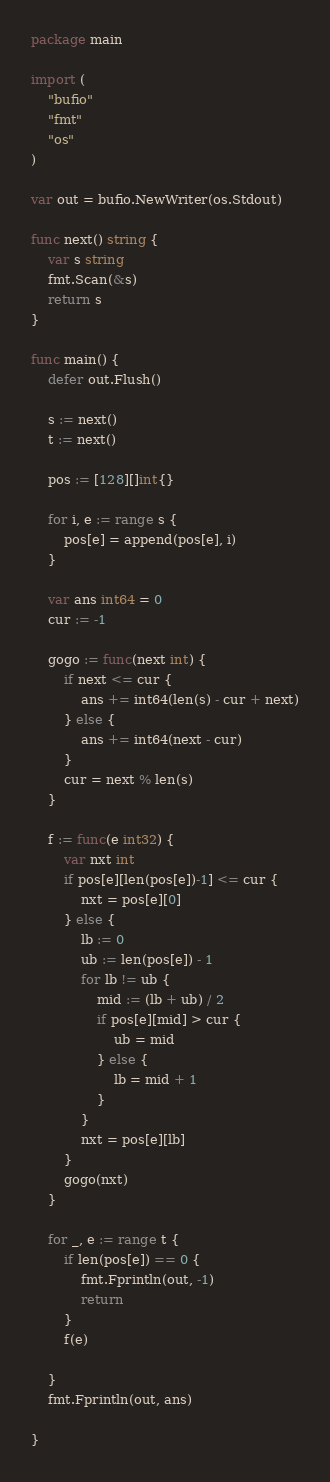<code> <loc_0><loc_0><loc_500><loc_500><_Go_>package main

import (
	"bufio"
	"fmt"
	"os"
)

var out = bufio.NewWriter(os.Stdout)

func next() string {
	var s string
	fmt.Scan(&s)
	return s
}

func main() {
	defer out.Flush()

	s := next()
	t := next()

	pos := [128][]int{}

	for i, e := range s {
		pos[e] = append(pos[e], i)
	}

	var ans int64 = 0
	cur := -1

	gogo := func(next int) {
		if next <= cur {
			ans += int64(len(s) - cur + next)
		} else {
			ans += int64(next - cur)
		}
		cur = next % len(s)
	}

	f := func(e int32) {
		var nxt int
		if pos[e][len(pos[e])-1] <= cur {
			nxt = pos[e][0]
		} else {
			lb := 0
			ub := len(pos[e]) - 1
			for lb != ub {
				mid := (lb + ub) / 2
				if pos[e][mid] > cur {
					ub = mid
				} else {
					lb = mid + 1
				}
			}
			nxt = pos[e][lb]
		}
		gogo(nxt)
	}

	for _, e := range t {
		if len(pos[e]) == 0 {
			fmt.Fprintln(out, -1)
			return
		}
		f(e)

	}
	fmt.Fprintln(out, ans)

}
</code> 